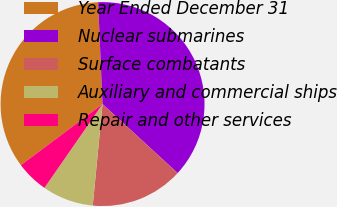Convert chart. <chart><loc_0><loc_0><loc_500><loc_500><pie_chart><fcel>Year Ended December 31<fcel>Nuclear submarines<fcel>Surface combatants<fcel>Auxiliary and commercial ships<fcel>Repair and other services<nl><fcel>34.53%<fcel>37.52%<fcel>14.7%<fcel>8.12%<fcel>5.12%<nl></chart> 